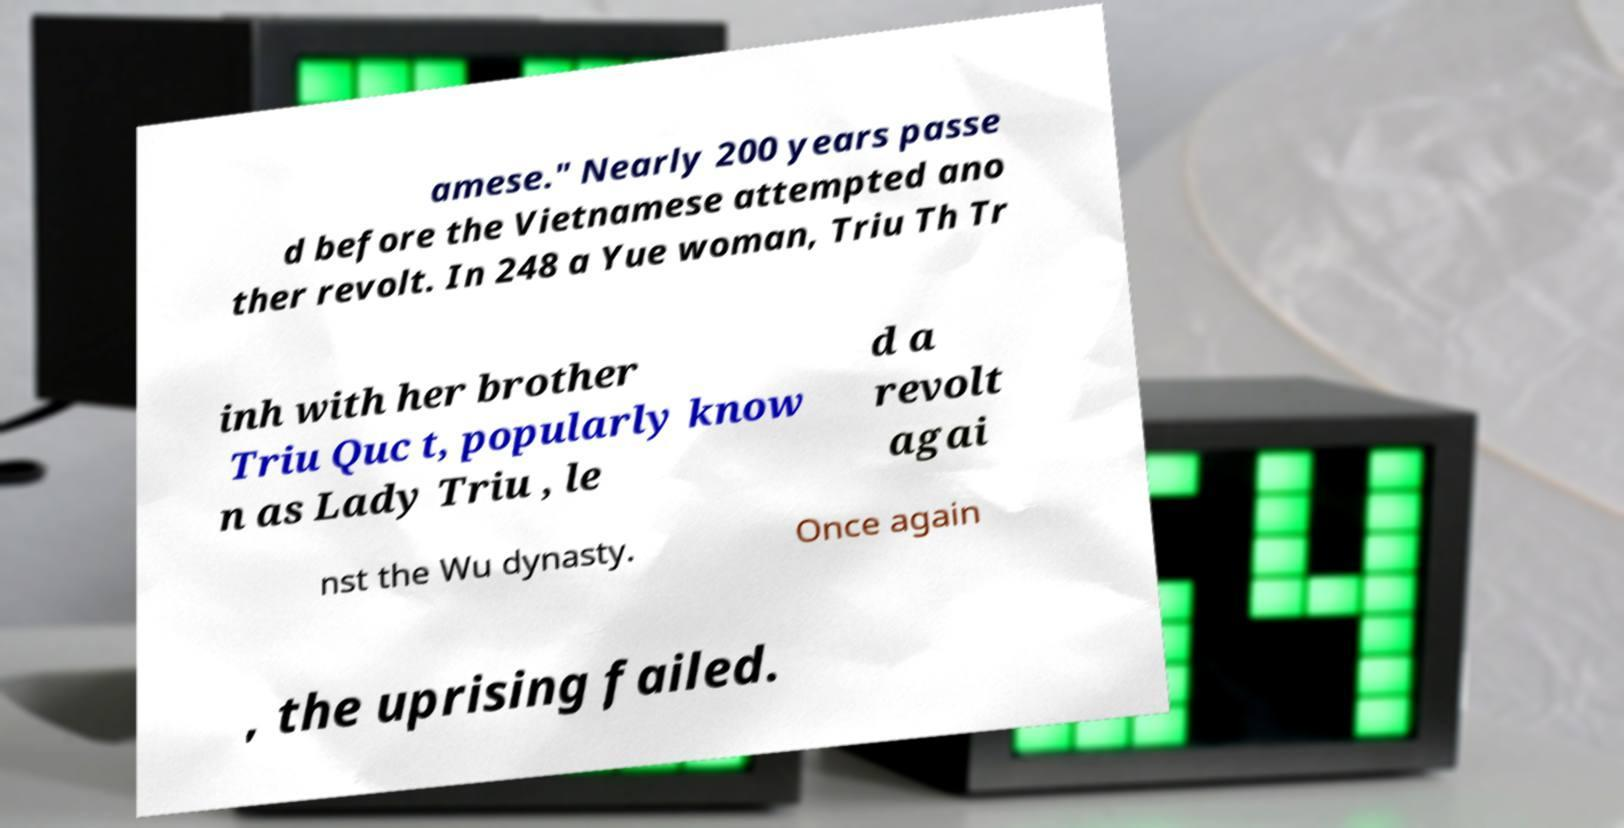Could you extract and type out the text from this image? amese." Nearly 200 years passe d before the Vietnamese attempted ano ther revolt. In 248 a Yue woman, Triu Th Tr inh with her brother Triu Quc t, popularly know n as Lady Triu , le d a revolt agai nst the Wu dynasty. Once again , the uprising failed. 